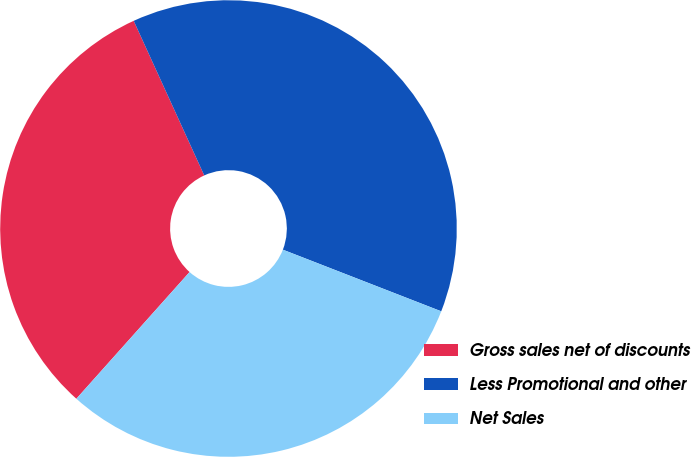<chart> <loc_0><loc_0><loc_500><loc_500><pie_chart><fcel>Gross sales net of discounts<fcel>Less Promotional and other<fcel>Net Sales<nl><fcel>31.58%<fcel>37.72%<fcel>30.7%<nl></chart> 